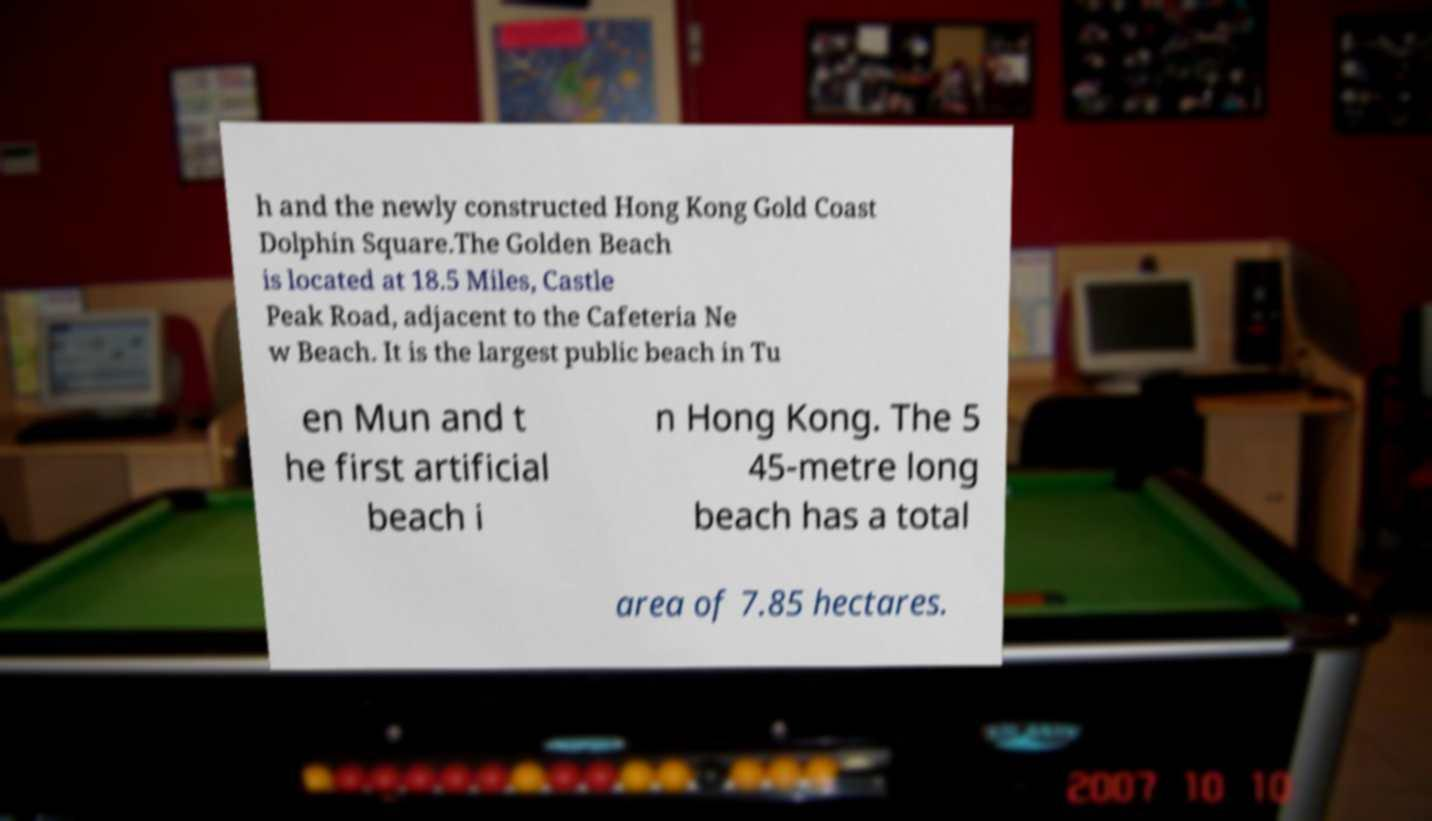Could you extract and type out the text from this image? h and the newly constructed Hong Kong Gold Coast Dolphin Square.The Golden Beach is located at 18.5 Miles, Castle Peak Road, adjacent to the Cafeteria Ne w Beach. It is the largest public beach in Tu en Mun and t he first artificial beach i n Hong Kong. The 5 45-metre long beach has a total area of 7.85 hectares. 